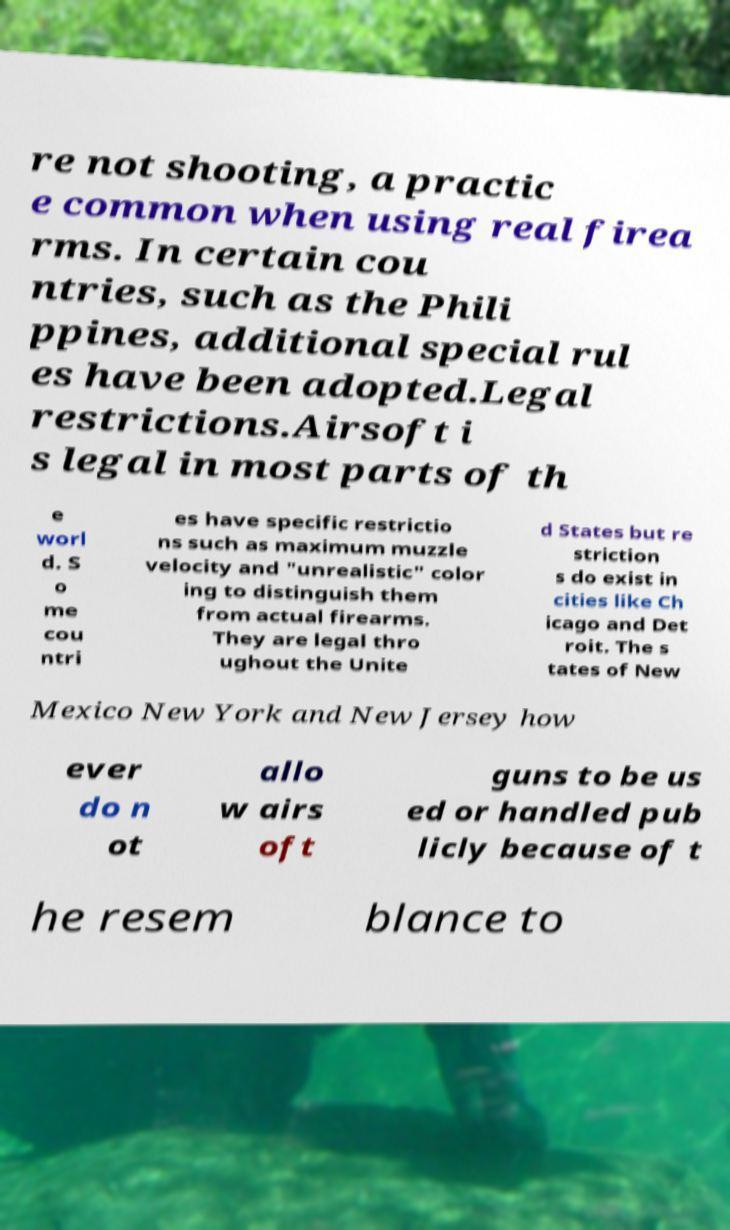Could you extract and type out the text from this image? re not shooting, a practic e common when using real firea rms. In certain cou ntries, such as the Phili ppines, additional special rul es have been adopted.Legal restrictions.Airsoft i s legal in most parts of th e worl d. S o me cou ntri es have specific restrictio ns such as maximum muzzle velocity and "unrealistic" color ing to distinguish them from actual firearms. They are legal thro ughout the Unite d States but re striction s do exist in cities like Ch icago and Det roit. The s tates of New Mexico New York and New Jersey how ever do n ot allo w airs oft guns to be us ed or handled pub licly because of t he resem blance to 